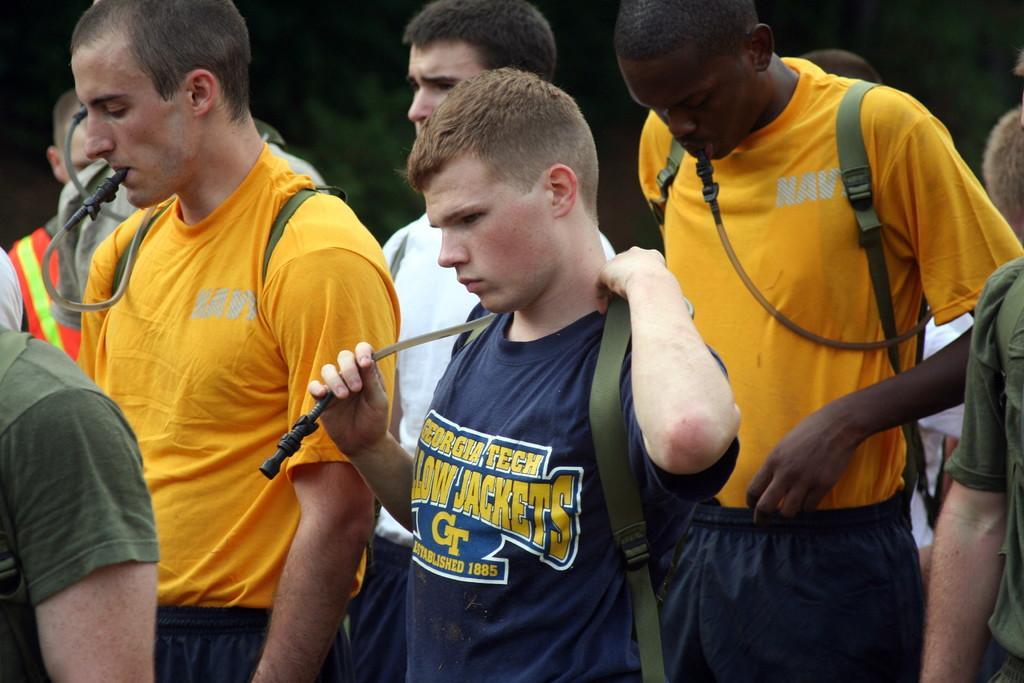Can you describe this image briefly? In this image in the foreground there are a group of people who are standing and some of them are wearing bags, and in the background there are some trees. 